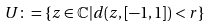Convert formula to latex. <formula><loc_0><loc_0><loc_500><loc_500>U \colon = \{ z \in \mathbb { C } | d ( z , [ - 1 , 1 ] ) < r \}</formula> 